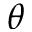<formula> <loc_0><loc_0><loc_500><loc_500>\theta</formula> 